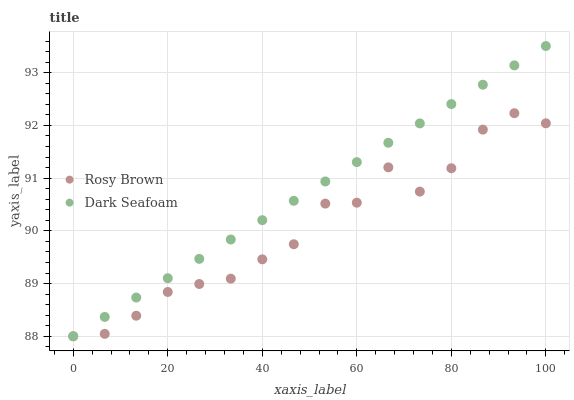Does Rosy Brown have the minimum area under the curve?
Answer yes or no. Yes. Does Dark Seafoam have the maximum area under the curve?
Answer yes or no. Yes. Does Rosy Brown have the maximum area under the curve?
Answer yes or no. No. Is Dark Seafoam the smoothest?
Answer yes or no. Yes. Is Rosy Brown the roughest?
Answer yes or no. Yes. Is Rosy Brown the smoothest?
Answer yes or no. No. Does Dark Seafoam have the lowest value?
Answer yes or no. Yes. Does Dark Seafoam have the highest value?
Answer yes or no. Yes. Does Rosy Brown have the highest value?
Answer yes or no. No. Does Rosy Brown intersect Dark Seafoam?
Answer yes or no. Yes. Is Rosy Brown less than Dark Seafoam?
Answer yes or no. No. Is Rosy Brown greater than Dark Seafoam?
Answer yes or no. No. 